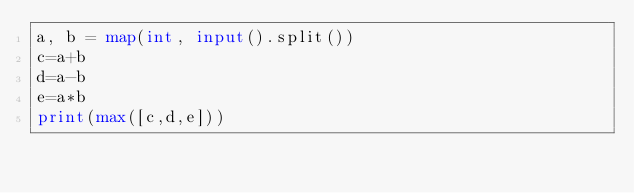Convert code to text. <code><loc_0><loc_0><loc_500><loc_500><_Python_>a, b = map(int, input().split())
c=a+b
d=a-b
e=a*b
print(max([c,d,e]))</code> 